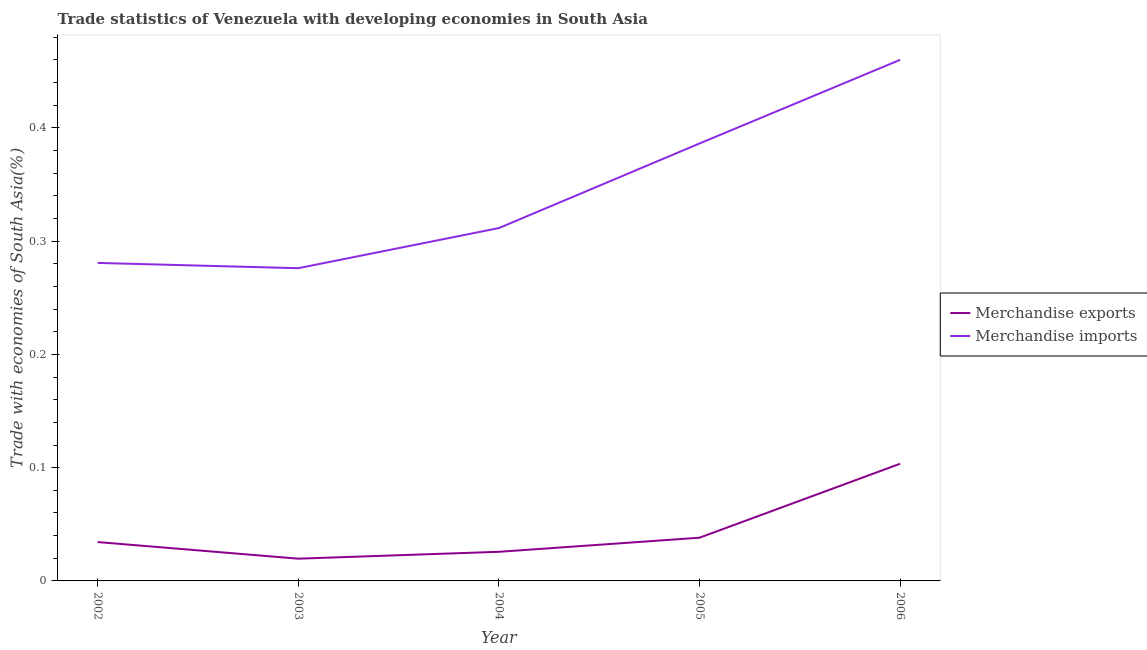How many different coloured lines are there?
Offer a terse response. 2. Does the line corresponding to merchandise exports intersect with the line corresponding to merchandise imports?
Provide a succinct answer. No. What is the merchandise exports in 2006?
Provide a succinct answer. 0.1. Across all years, what is the maximum merchandise imports?
Your answer should be very brief. 0.46. Across all years, what is the minimum merchandise exports?
Your answer should be compact. 0.02. In which year was the merchandise exports maximum?
Your response must be concise. 2006. In which year was the merchandise imports minimum?
Keep it short and to the point. 2003. What is the total merchandise imports in the graph?
Provide a succinct answer. 1.71. What is the difference between the merchandise exports in 2004 and that in 2006?
Keep it short and to the point. -0.08. What is the difference between the merchandise exports in 2004 and the merchandise imports in 2005?
Your answer should be very brief. -0.36. What is the average merchandise exports per year?
Provide a short and direct response. 0.04. In the year 2003, what is the difference between the merchandise imports and merchandise exports?
Your answer should be very brief. 0.26. What is the ratio of the merchandise exports in 2004 to that in 2005?
Provide a short and direct response. 0.67. What is the difference between the highest and the second highest merchandise exports?
Your response must be concise. 0.07. What is the difference between the highest and the lowest merchandise imports?
Make the answer very short. 0.18. Is the sum of the merchandise exports in 2002 and 2005 greater than the maximum merchandise imports across all years?
Your response must be concise. No. Does the merchandise exports monotonically increase over the years?
Your response must be concise. No. How many years are there in the graph?
Ensure brevity in your answer.  5. Are the values on the major ticks of Y-axis written in scientific E-notation?
Offer a very short reply. No. Does the graph contain grids?
Your answer should be very brief. No. How many legend labels are there?
Keep it short and to the point. 2. What is the title of the graph?
Your response must be concise. Trade statistics of Venezuela with developing economies in South Asia. What is the label or title of the X-axis?
Provide a succinct answer. Year. What is the label or title of the Y-axis?
Make the answer very short. Trade with economies of South Asia(%). What is the Trade with economies of South Asia(%) in Merchandise exports in 2002?
Offer a very short reply. 0.03. What is the Trade with economies of South Asia(%) in Merchandise imports in 2002?
Provide a succinct answer. 0.28. What is the Trade with economies of South Asia(%) of Merchandise exports in 2003?
Offer a very short reply. 0.02. What is the Trade with economies of South Asia(%) in Merchandise imports in 2003?
Provide a succinct answer. 0.28. What is the Trade with economies of South Asia(%) of Merchandise exports in 2004?
Provide a succinct answer. 0.03. What is the Trade with economies of South Asia(%) of Merchandise imports in 2004?
Make the answer very short. 0.31. What is the Trade with economies of South Asia(%) of Merchandise exports in 2005?
Your response must be concise. 0.04. What is the Trade with economies of South Asia(%) of Merchandise imports in 2005?
Offer a terse response. 0.39. What is the Trade with economies of South Asia(%) in Merchandise exports in 2006?
Ensure brevity in your answer.  0.1. What is the Trade with economies of South Asia(%) in Merchandise imports in 2006?
Offer a terse response. 0.46. Across all years, what is the maximum Trade with economies of South Asia(%) in Merchandise exports?
Ensure brevity in your answer.  0.1. Across all years, what is the maximum Trade with economies of South Asia(%) of Merchandise imports?
Your answer should be very brief. 0.46. Across all years, what is the minimum Trade with economies of South Asia(%) in Merchandise exports?
Ensure brevity in your answer.  0.02. Across all years, what is the minimum Trade with economies of South Asia(%) in Merchandise imports?
Your answer should be very brief. 0.28. What is the total Trade with economies of South Asia(%) of Merchandise exports in the graph?
Give a very brief answer. 0.22. What is the total Trade with economies of South Asia(%) in Merchandise imports in the graph?
Your answer should be very brief. 1.71. What is the difference between the Trade with economies of South Asia(%) in Merchandise exports in 2002 and that in 2003?
Offer a very short reply. 0.01. What is the difference between the Trade with economies of South Asia(%) of Merchandise imports in 2002 and that in 2003?
Your response must be concise. 0. What is the difference between the Trade with economies of South Asia(%) in Merchandise exports in 2002 and that in 2004?
Your response must be concise. 0.01. What is the difference between the Trade with economies of South Asia(%) of Merchandise imports in 2002 and that in 2004?
Provide a short and direct response. -0.03. What is the difference between the Trade with economies of South Asia(%) of Merchandise exports in 2002 and that in 2005?
Your answer should be compact. -0. What is the difference between the Trade with economies of South Asia(%) in Merchandise imports in 2002 and that in 2005?
Your response must be concise. -0.11. What is the difference between the Trade with economies of South Asia(%) of Merchandise exports in 2002 and that in 2006?
Provide a short and direct response. -0.07. What is the difference between the Trade with economies of South Asia(%) of Merchandise imports in 2002 and that in 2006?
Your response must be concise. -0.18. What is the difference between the Trade with economies of South Asia(%) of Merchandise exports in 2003 and that in 2004?
Provide a succinct answer. -0.01. What is the difference between the Trade with economies of South Asia(%) in Merchandise imports in 2003 and that in 2004?
Keep it short and to the point. -0.04. What is the difference between the Trade with economies of South Asia(%) in Merchandise exports in 2003 and that in 2005?
Your response must be concise. -0.02. What is the difference between the Trade with economies of South Asia(%) of Merchandise imports in 2003 and that in 2005?
Your response must be concise. -0.11. What is the difference between the Trade with economies of South Asia(%) of Merchandise exports in 2003 and that in 2006?
Give a very brief answer. -0.08. What is the difference between the Trade with economies of South Asia(%) of Merchandise imports in 2003 and that in 2006?
Offer a very short reply. -0.18. What is the difference between the Trade with economies of South Asia(%) of Merchandise exports in 2004 and that in 2005?
Keep it short and to the point. -0.01. What is the difference between the Trade with economies of South Asia(%) of Merchandise imports in 2004 and that in 2005?
Provide a short and direct response. -0.07. What is the difference between the Trade with economies of South Asia(%) of Merchandise exports in 2004 and that in 2006?
Make the answer very short. -0.08. What is the difference between the Trade with economies of South Asia(%) in Merchandise imports in 2004 and that in 2006?
Offer a terse response. -0.15. What is the difference between the Trade with economies of South Asia(%) of Merchandise exports in 2005 and that in 2006?
Make the answer very short. -0.07. What is the difference between the Trade with economies of South Asia(%) in Merchandise imports in 2005 and that in 2006?
Offer a very short reply. -0.07. What is the difference between the Trade with economies of South Asia(%) of Merchandise exports in 2002 and the Trade with economies of South Asia(%) of Merchandise imports in 2003?
Offer a terse response. -0.24. What is the difference between the Trade with economies of South Asia(%) of Merchandise exports in 2002 and the Trade with economies of South Asia(%) of Merchandise imports in 2004?
Offer a terse response. -0.28. What is the difference between the Trade with economies of South Asia(%) of Merchandise exports in 2002 and the Trade with economies of South Asia(%) of Merchandise imports in 2005?
Your response must be concise. -0.35. What is the difference between the Trade with economies of South Asia(%) of Merchandise exports in 2002 and the Trade with economies of South Asia(%) of Merchandise imports in 2006?
Make the answer very short. -0.43. What is the difference between the Trade with economies of South Asia(%) of Merchandise exports in 2003 and the Trade with economies of South Asia(%) of Merchandise imports in 2004?
Make the answer very short. -0.29. What is the difference between the Trade with economies of South Asia(%) of Merchandise exports in 2003 and the Trade with economies of South Asia(%) of Merchandise imports in 2005?
Offer a terse response. -0.37. What is the difference between the Trade with economies of South Asia(%) of Merchandise exports in 2003 and the Trade with economies of South Asia(%) of Merchandise imports in 2006?
Provide a succinct answer. -0.44. What is the difference between the Trade with economies of South Asia(%) of Merchandise exports in 2004 and the Trade with economies of South Asia(%) of Merchandise imports in 2005?
Offer a terse response. -0.36. What is the difference between the Trade with economies of South Asia(%) in Merchandise exports in 2004 and the Trade with economies of South Asia(%) in Merchandise imports in 2006?
Your response must be concise. -0.43. What is the difference between the Trade with economies of South Asia(%) in Merchandise exports in 2005 and the Trade with economies of South Asia(%) in Merchandise imports in 2006?
Your answer should be compact. -0.42. What is the average Trade with economies of South Asia(%) of Merchandise exports per year?
Provide a short and direct response. 0.04. What is the average Trade with economies of South Asia(%) in Merchandise imports per year?
Your answer should be very brief. 0.34. In the year 2002, what is the difference between the Trade with economies of South Asia(%) in Merchandise exports and Trade with economies of South Asia(%) in Merchandise imports?
Make the answer very short. -0.25. In the year 2003, what is the difference between the Trade with economies of South Asia(%) in Merchandise exports and Trade with economies of South Asia(%) in Merchandise imports?
Give a very brief answer. -0.26. In the year 2004, what is the difference between the Trade with economies of South Asia(%) in Merchandise exports and Trade with economies of South Asia(%) in Merchandise imports?
Your response must be concise. -0.29. In the year 2005, what is the difference between the Trade with economies of South Asia(%) of Merchandise exports and Trade with economies of South Asia(%) of Merchandise imports?
Ensure brevity in your answer.  -0.35. In the year 2006, what is the difference between the Trade with economies of South Asia(%) in Merchandise exports and Trade with economies of South Asia(%) in Merchandise imports?
Offer a very short reply. -0.36. What is the ratio of the Trade with economies of South Asia(%) in Merchandise exports in 2002 to that in 2003?
Make the answer very short. 1.75. What is the ratio of the Trade with economies of South Asia(%) in Merchandise imports in 2002 to that in 2003?
Your answer should be compact. 1.02. What is the ratio of the Trade with economies of South Asia(%) in Merchandise exports in 2002 to that in 2004?
Keep it short and to the point. 1.33. What is the ratio of the Trade with economies of South Asia(%) of Merchandise imports in 2002 to that in 2004?
Make the answer very short. 0.9. What is the ratio of the Trade with economies of South Asia(%) of Merchandise exports in 2002 to that in 2005?
Your answer should be very brief. 0.9. What is the ratio of the Trade with economies of South Asia(%) in Merchandise imports in 2002 to that in 2005?
Provide a short and direct response. 0.73. What is the ratio of the Trade with economies of South Asia(%) in Merchandise exports in 2002 to that in 2006?
Provide a succinct answer. 0.33. What is the ratio of the Trade with economies of South Asia(%) of Merchandise imports in 2002 to that in 2006?
Keep it short and to the point. 0.61. What is the ratio of the Trade with economies of South Asia(%) in Merchandise exports in 2003 to that in 2004?
Offer a very short reply. 0.76. What is the ratio of the Trade with economies of South Asia(%) in Merchandise imports in 2003 to that in 2004?
Your response must be concise. 0.89. What is the ratio of the Trade with economies of South Asia(%) of Merchandise exports in 2003 to that in 2005?
Give a very brief answer. 0.51. What is the ratio of the Trade with economies of South Asia(%) in Merchandise imports in 2003 to that in 2005?
Keep it short and to the point. 0.71. What is the ratio of the Trade with economies of South Asia(%) in Merchandise exports in 2003 to that in 2006?
Your response must be concise. 0.19. What is the ratio of the Trade with economies of South Asia(%) of Merchandise imports in 2003 to that in 2006?
Provide a short and direct response. 0.6. What is the ratio of the Trade with economies of South Asia(%) in Merchandise exports in 2004 to that in 2005?
Give a very brief answer. 0.67. What is the ratio of the Trade with economies of South Asia(%) in Merchandise imports in 2004 to that in 2005?
Provide a succinct answer. 0.81. What is the ratio of the Trade with economies of South Asia(%) of Merchandise exports in 2004 to that in 2006?
Give a very brief answer. 0.25. What is the ratio of the Trade with economies of South Asia(%) in Merchandise imports in 2004 to that in 2006?
Make the answer very short. 0.68. What is the ratio of the Trade with economies of South Asia(%) in Merchandise exports in 2005 to that in 2006?
Your answer should be very brief. 0.37. What is the ratio of the Trade with economies of South Asia(%) of Merchandise imports in 2005 to that in 2006?
Provide a succinct answer. 0.84. What is the difference between the highest and the second highest Trade with economies of South Asia(%) of Merchandise exports?
Keep it short and to the point. 0.07. What is the difference between the highest and the second highest Trade with economies of South Asia(%) of Merchandise imports?
Keep it short and to the point. 0.07. What is the difference between the highest and the lowest Trade with economies of South Asia(%) of Merchandise exports?
Provide a short and direct response. 0.08. What is the difference between the highest and the lowest Trade with economies of South Asia(%) of Merchandise imports?
Your response must be concise. 0.18. 